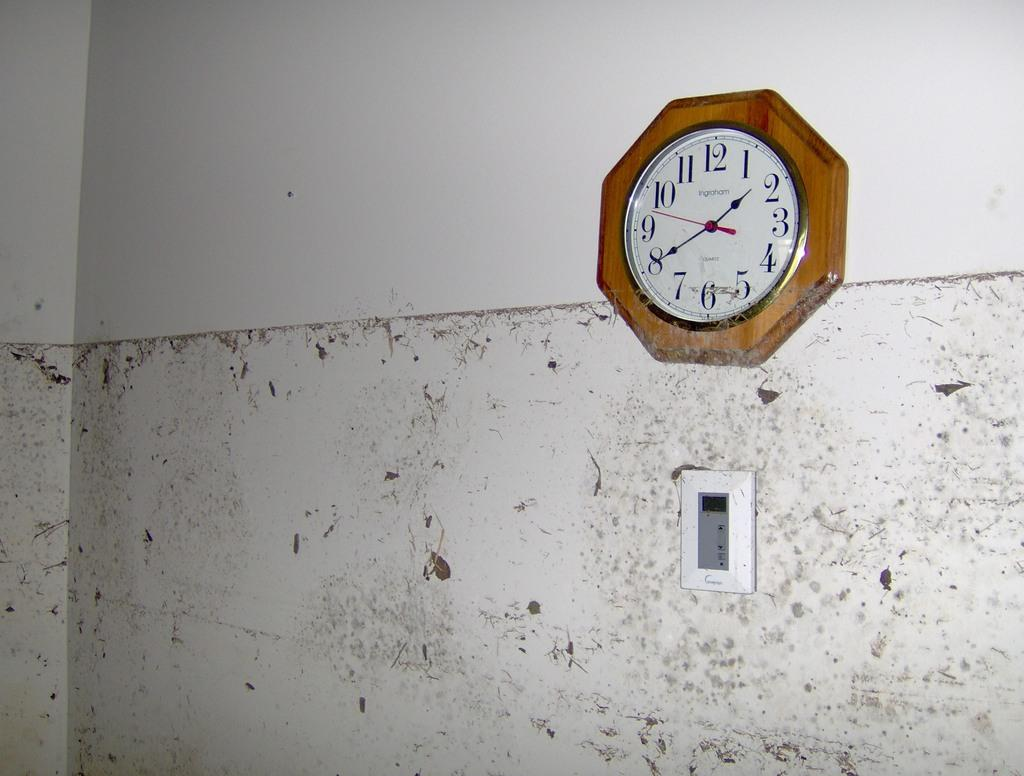<image>
Give a short and clear explanation of the subsequent image. Old brown clock with the hands currently on the numbers 2 and 8. 